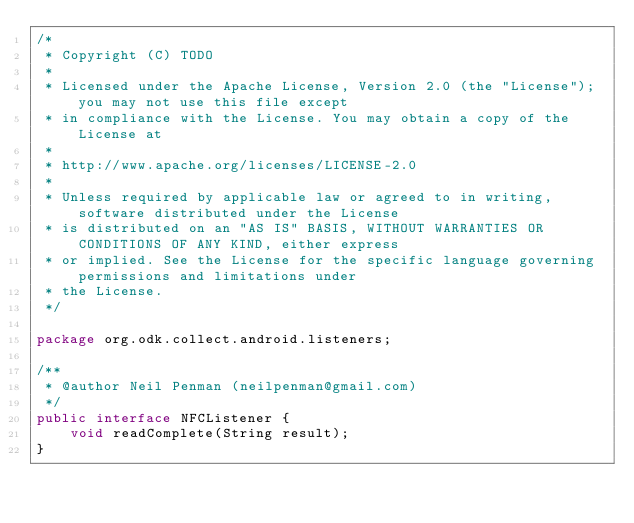<code> <loc_0><loc_0><loc_500><loc_500><_Java_>/*
 * Copyright (C) TODO
 * 
 * Licensed under the Apache License, Version 2.0 (the "License"); you may not use this file except
 * in compliance with the License. You may obtain a copy of the License at
 * 
 * http://www.apache.org/licenses/LICENSE-2.0
 * 
 * Unless required by applicable law or agreed to in writing, software distributed under the License
 * is distributed on an "AS IS" BASIS, WITHOUT WARRANTIES OR CONDITIONS OF ANY KIND, either express
 * or implied. See the License for the specific language governing permissions and limitations under
 * the License.
 */

package org.odk.collect.android.listeners;

/**
 * @author Neil Penman (neilpenman@gmail.com)
 */
public interface NFCListener {
    void readComplete(String result);
}
</code> 